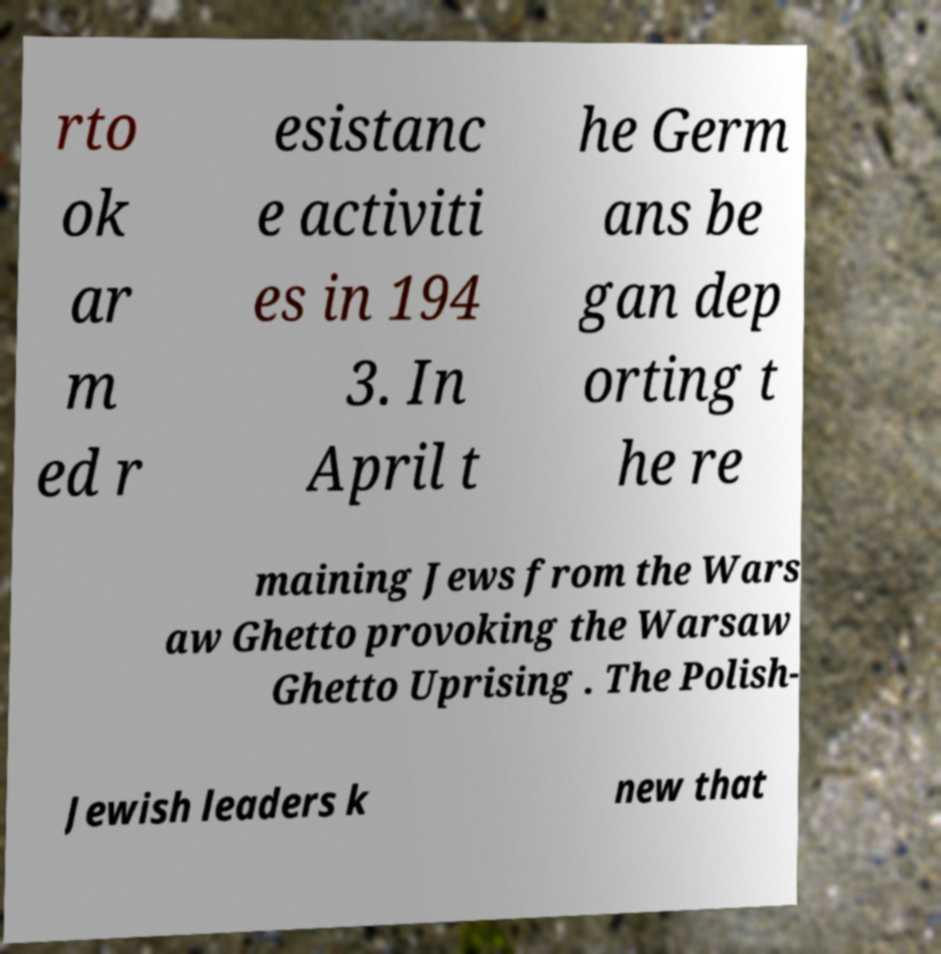Can you read and provide the text displayed in the image?This photo seems to have some interesting text. Can you extract and type it out for me? rto ok ar m ed r esistanc e activiti es in 194 3. In April t he Germ ans be gan dep orting t he re maining Jews from the Wars aw Ghetto provoking the Warsaw Ghetto Uprising . The Polish- Jewish leaders k new that 